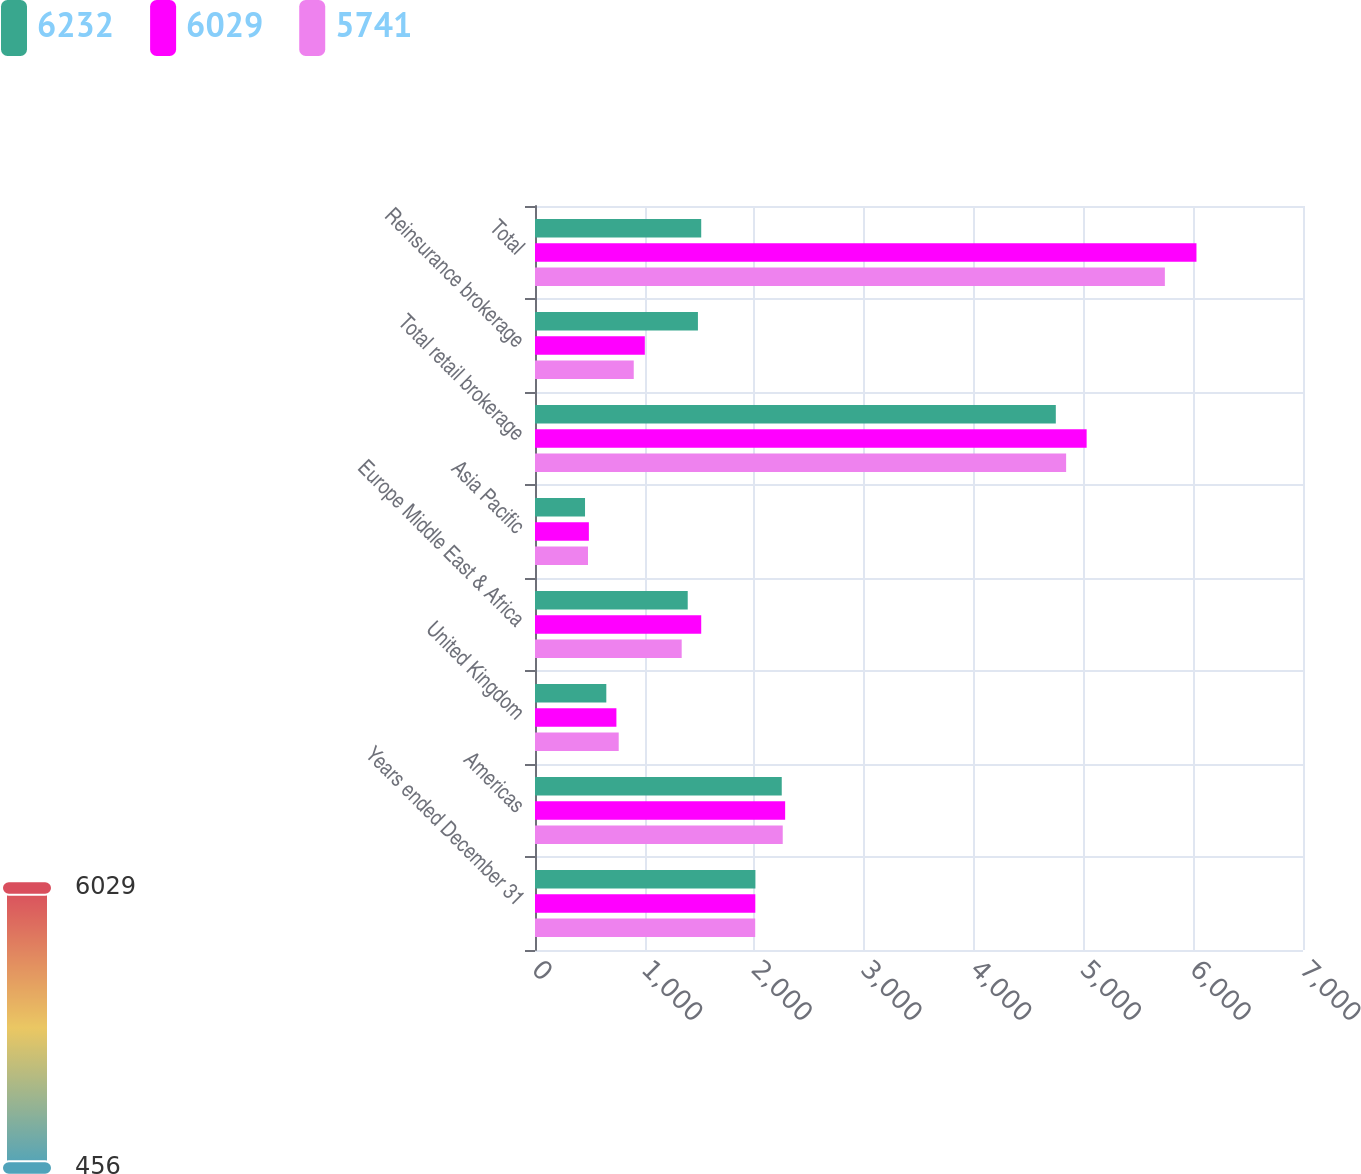Convert chart. <chart><loc_0><loc_0><loc_500><loc_500><stacked_bar_chart><ecel><fcel>Years ended December 31<fcel>Americas<fcel>United Kingdom<fcel>Europe Middle East & Africa<fcel>Asia Pacific<fcel>Total retail brokerage<fcel>Reinsurance brokerage<fcel>Total<nl><fcel>6232<fcel>2009<fcel>2249<fcel>650<fcel>1392<fcel>456<fcel>4747<fcel>1485<fcel>1515<nl><fcel>6029<fcel>2008<fcel>2280<fcel>742<fcel>1515<fcel>491<fcel>5028<fcel>1001<fcel>6029<nl><fcel>5741<fcel>2007<fcel>2258<fcel>763<fcel>1337<fcel>483<fcel>4841<fcel>900<fcel>5741<nl></chart> 